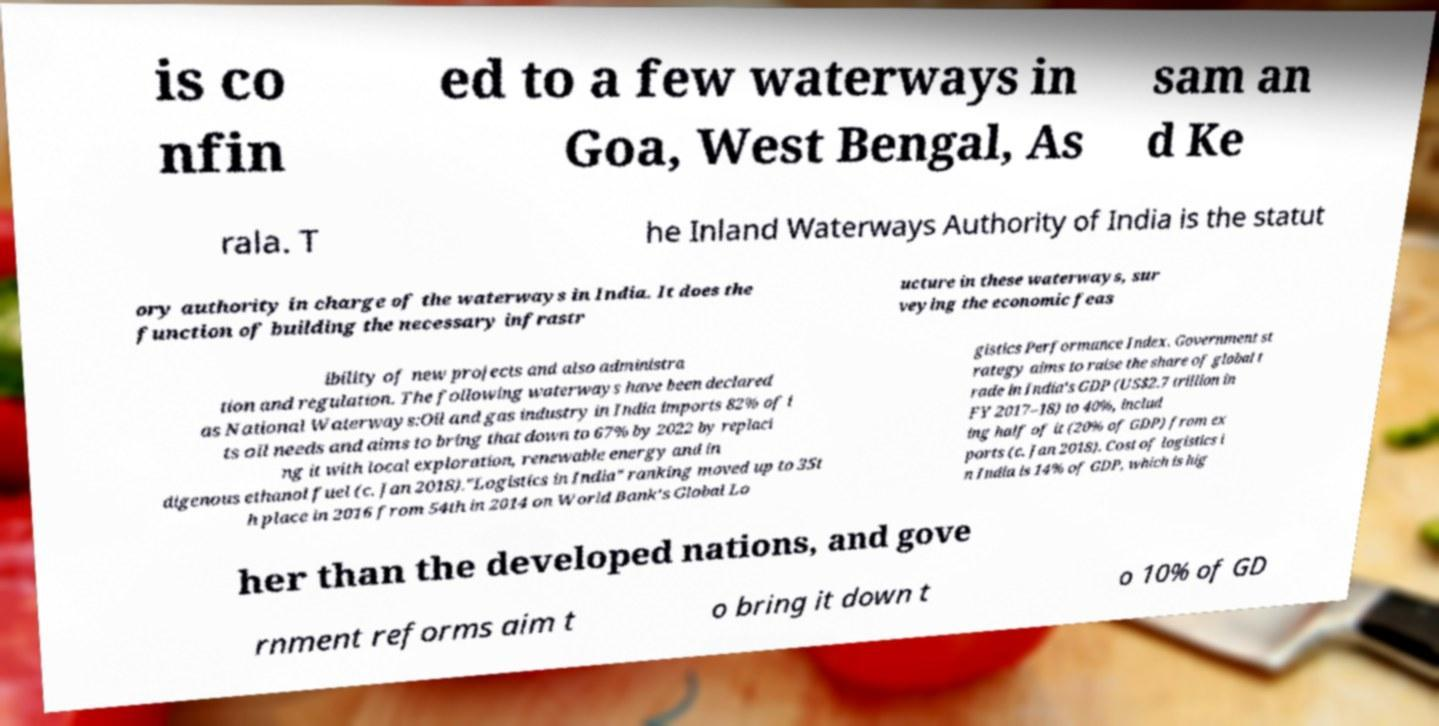Can you read and provide the text displayed in the image?This photo seems to have some interesting text. Can you extract and type it out for me? is co nfin ed to a few waterways in Goa, West Bengal, As sam an d Ke rala. T he Inland Waterways Authority of India is the statut ory authority in charge of the waterways in India. It does the function of building the necessary infrastr ucture in these waterways, sur veying the economic feas ibility of new projects and also administra tion and regulation. The following waterways have been declared as National Waterways:Oil and gas industry in India imports 82% of i ts oil needs and aims to bring that down to 67% by 2022 by replaci ng it with local exploration, renewable energy and in digenous ethanol fuel (c. Jan 2018)."Logistics in India" ranking moved up to 35t h place in 2016 from 54th in 2014 on World Bank's Global Lo gistics Performance Index. Government st rategy aims to raise the share of global t rade in India's GDP (US$2.7 trillion in FY 2017–18) to 40%, includ ing half of it (20% of GDP) from ex ports (c. Jan 2018). Cost of logistics i n India is 14% of GDP, which is hig her than the developed nations, and gove rnment reforms aim t o bring it down t o 10% of GD 